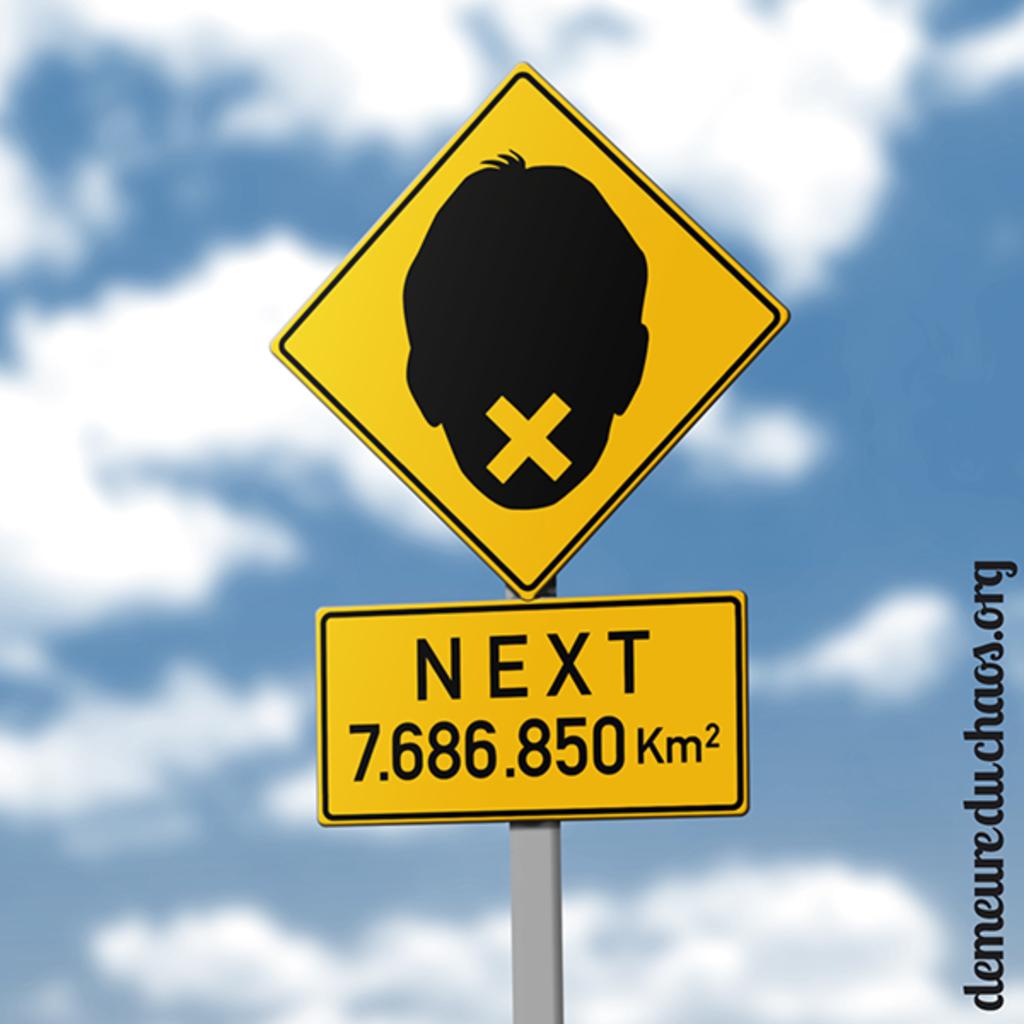What is the website in the photo?
Provide a succinct answer. Demeureduchaos.org. 